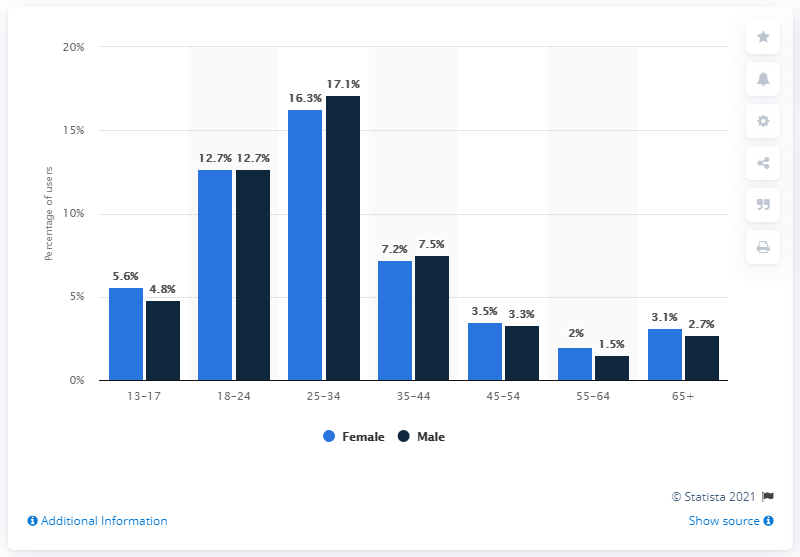Point out several critical features in this image. According to a recent study, only 5.6% of South Africa's social media audience were female teenagers between the ages of 13 and 17 years. 